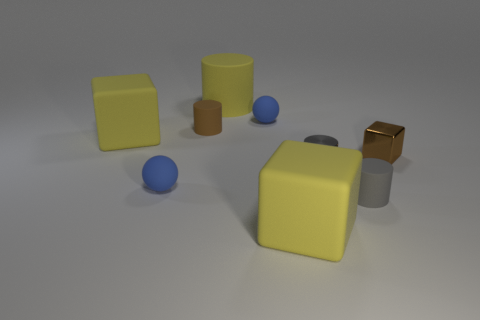How many geometric shapes are displayed in the image, and can you describe them? The image features six geometric shapes: two spheres, two cubes, and two cylinders. The spheres and cylinders showcase a cool blue and a muted yellow respectively, while the cubes are presented in a soft yellow and a reflective bronze tone. 